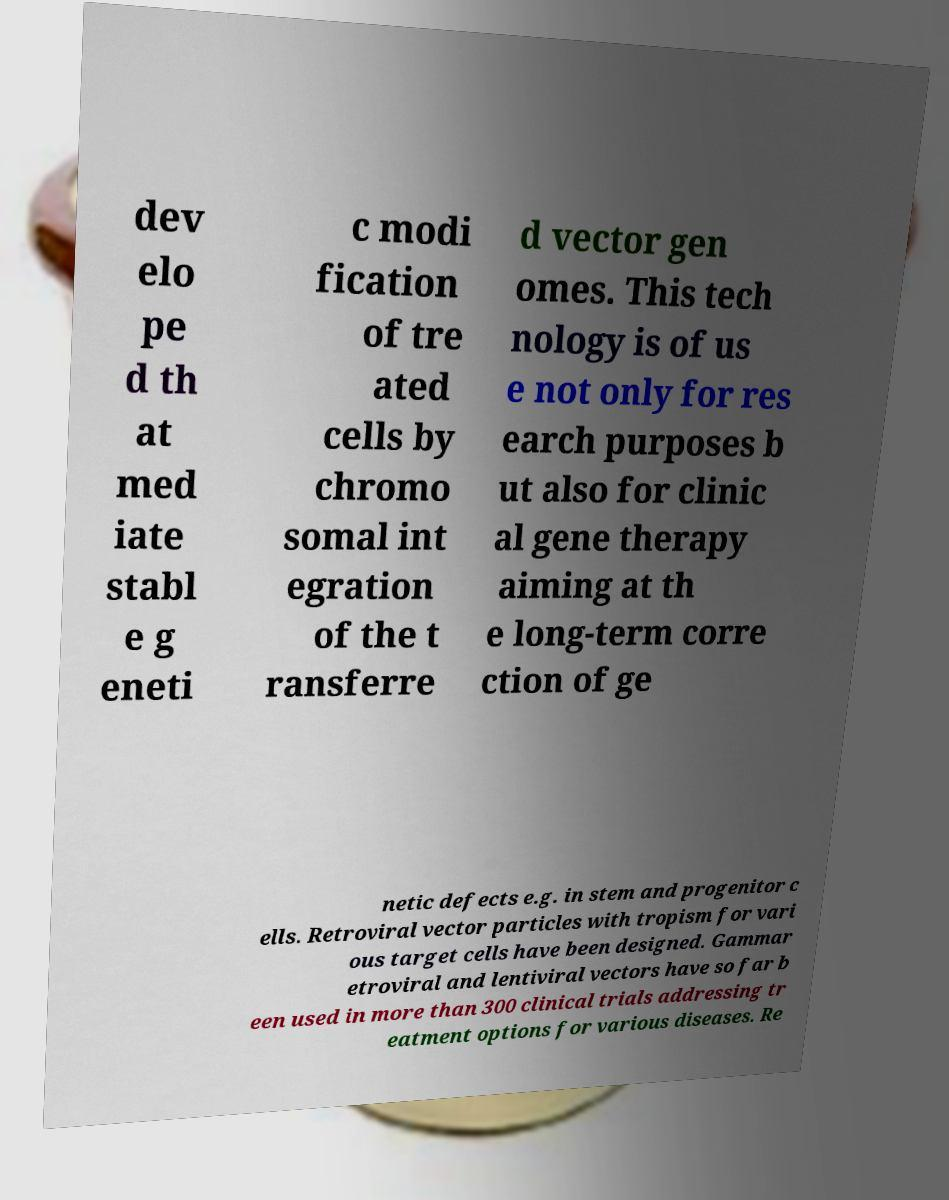There's text embedded in this image that I need extracted. Can you transcribe it verbatim? dev elo pe d th at med iate stabl e g eneti c modi fication of tre ated cells by chromo somal int egration of the t ransferre d vector gen omes. This tech nology is of us e not only for res earch purposes b ut also for clinic al gene therapy aiming at th e long-term corre ction of ge netic defects e.g. in stem and progenitor c ells. Retroviral vector particles with tropism for vari ous target cells have been designed. Gammar etroviral and lentiviral vectors have so far b een used in more than 300 clinical trials addressing tr eatment options for various diseases. Re 